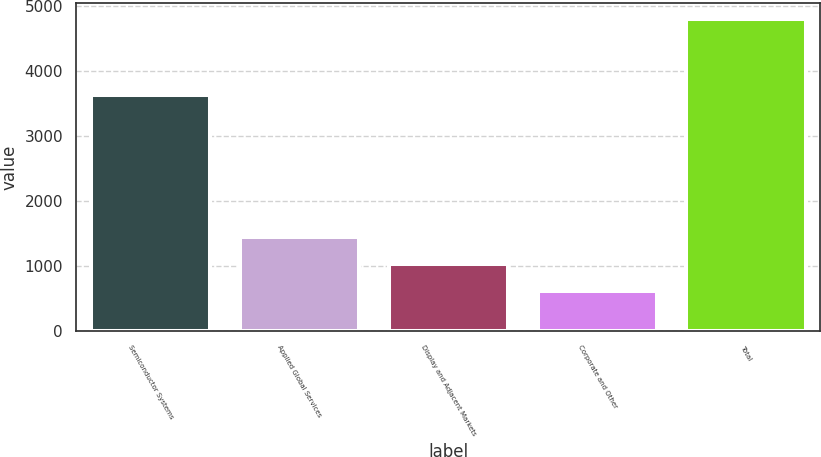Convert chart to OTSL. <chart><loc_0><loc_0><loc_500><loc_500><bar_chart><fcel>Semiconductor Systems<fcel>Applied Global Services<fcel>Display and Adjacent Markets<fcel>Corporate and Other<fcel>Total<nl><fcel>3634<fcel>1454.4<fcel>1036.7<fcel>619<fcel>4796<nl></chart> 